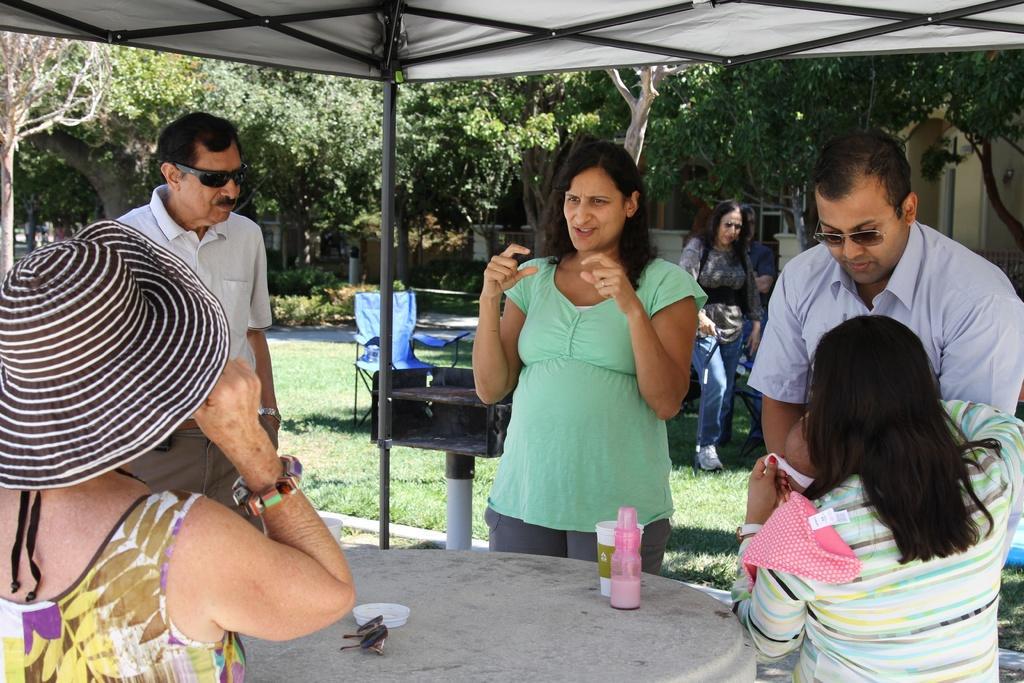Describe this image in one or two sentences. This picture shows a group of people standing and we see a woman seated and we see a bottle,and a cup and sunglasses on the table, and we see a woman walking on the back and We see trees around and we see two men wearing sunglasses on their face and woman wearing hat 